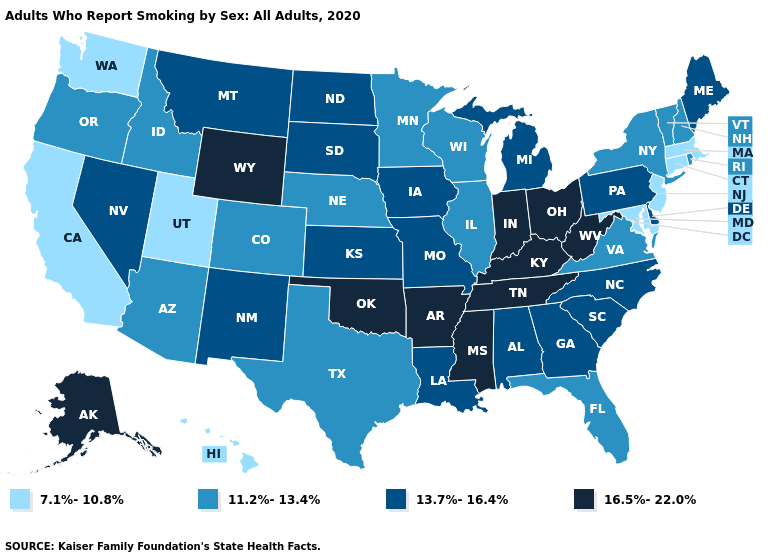What is the lowest value in the MidWest?
Give a very brief answer. 11.2%-13.4%. Name the states that have a value in the range 11.2%-13.4%?
Answer briefly. Arizona, Colorado, Florida, Idaho, Illinois, Minnesota, Nebraska, New Hampshire, New York, Oregon, Rhode Island, Texas, Vermont, Virginia, Wisconsin. What is the value of Michigan?
Write a very short answer. 13.7%-16.4%. What is the lowest value in the USA?
Keep it brief. 7.1%-10.8%. Does Idaho have a lower value than West Virginia?
Answer briefly. Yes. Name the states that have a value in the range 7.1%-10.8%?
Quick response, please. California, Connecticut, Hawaii, Maryland, Massachusetts, New Jersey, Utah, Washington. What is the value of Maine?
Be succinct. 13.7%-16.4%. Does South Dakota have the lowest value in the MidWest?
Give a very brief answer. No. What is the value of Vermont?
Give a very brief answer. 11.2%-13.4%. Name the states that have a value in the range 16.5%-22.0%?
Be succinct. Alaska, Arkansas, Indiana, Kentucky, Mississippi, Ohio, Oklahoma, Tennessee, West Virginia, Wyoming. What is the value of Florida?
Quick response, please. 11.2%-13.4%. What is the value of Vermont?
Write a very short answer. 11.2%-13.4%. Name the states that have a value in the range 11.2%-13.4%?
Write a very short answer. Arizona, Colorado, Florida, Idaho, Illinois, Minnesota, Nebraska, New Hampshire, New York, Oregon, Rhode Island, Texas, Vermont, Virginia, Wisconsin. What is the highest value in the West ?
Quick response, please. 16.5%-22.0%. Name the states that have a value in the range 11.2%-13.4%?
Give a very brief answer. Arizona, Colorado, Florida, Idaho, Illinois, Minnesota, Nebraska, New Hampshire, New York, Oregon, Rhode Island, Texas, Vermont, Virginia, Wisconsin. 